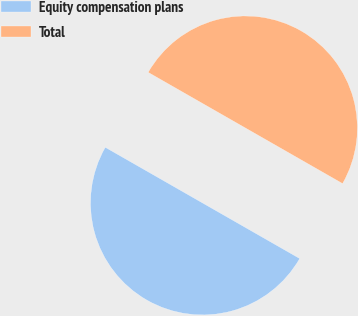<chart> <loc_0><loc_0><loc_500><loc_500><pie_chart><fcel>Equity compensation plans<fcel>Total<nl><fcel>50.0%<fcel>50.0%<nl></chart> 